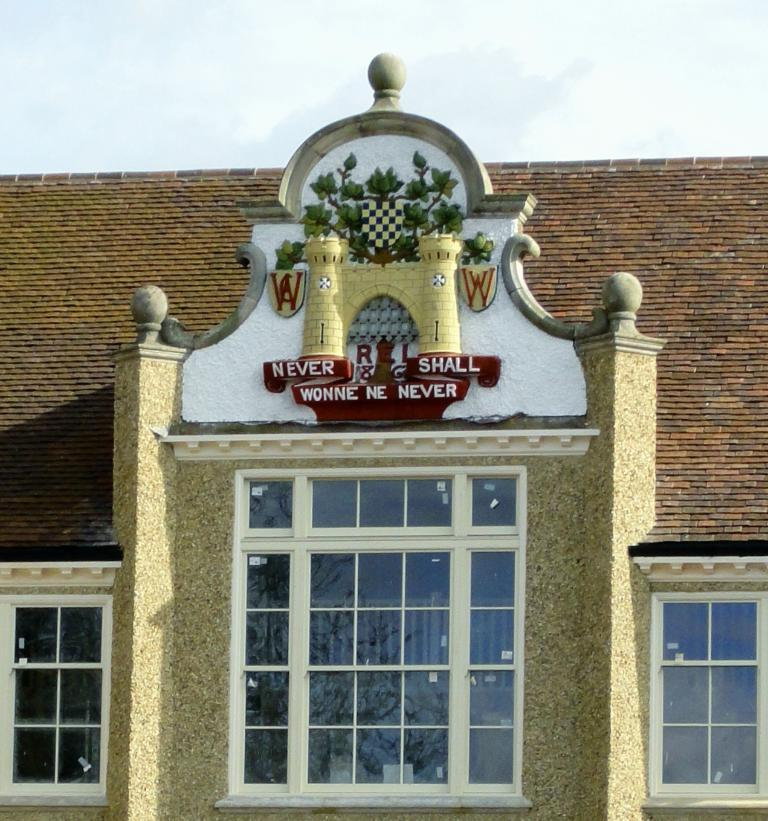What type of structure is in the image? There is a building in the image. What feature of the building can be seen? There are windows in the building. Is there any text visible in the image? Yes, there is some text visible in the image. What can be seen in the sky at the top of the image? Clouds are present in the sky at the top of the image. How many eggs are visible on the building in the image? There are no eggs present on the building in the image. What type of country is depicted in the image? The image does not depict a country; it shows a building with windows and text, along with clouds in the sky. 